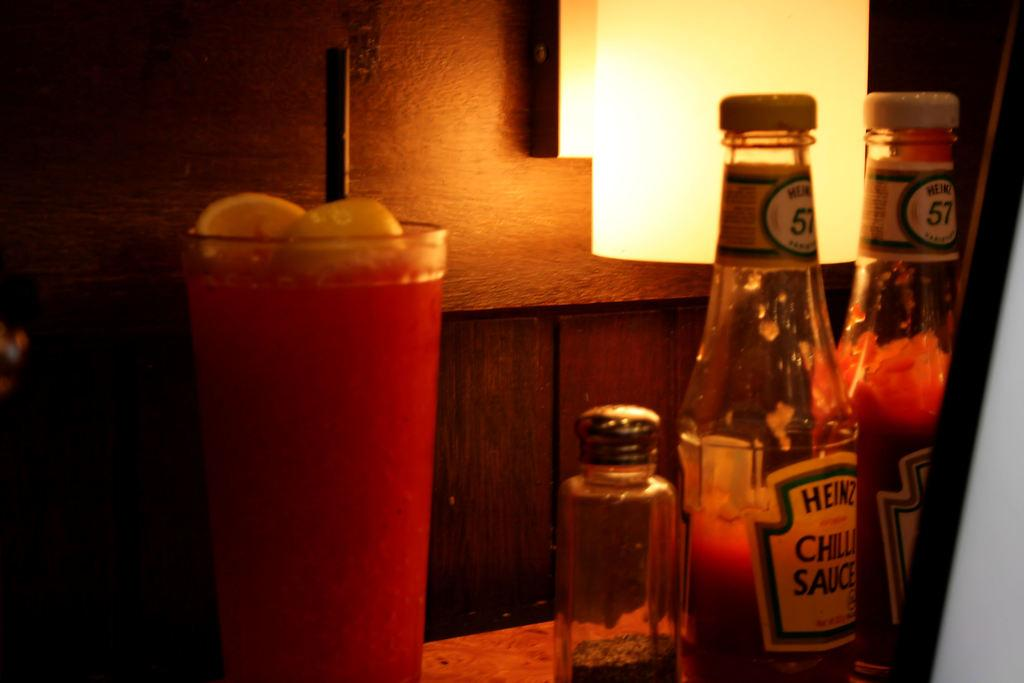<image>
Render a clear and concise summary of the photo. On a table are two bottles, one bottle is Chilli Sauce. 